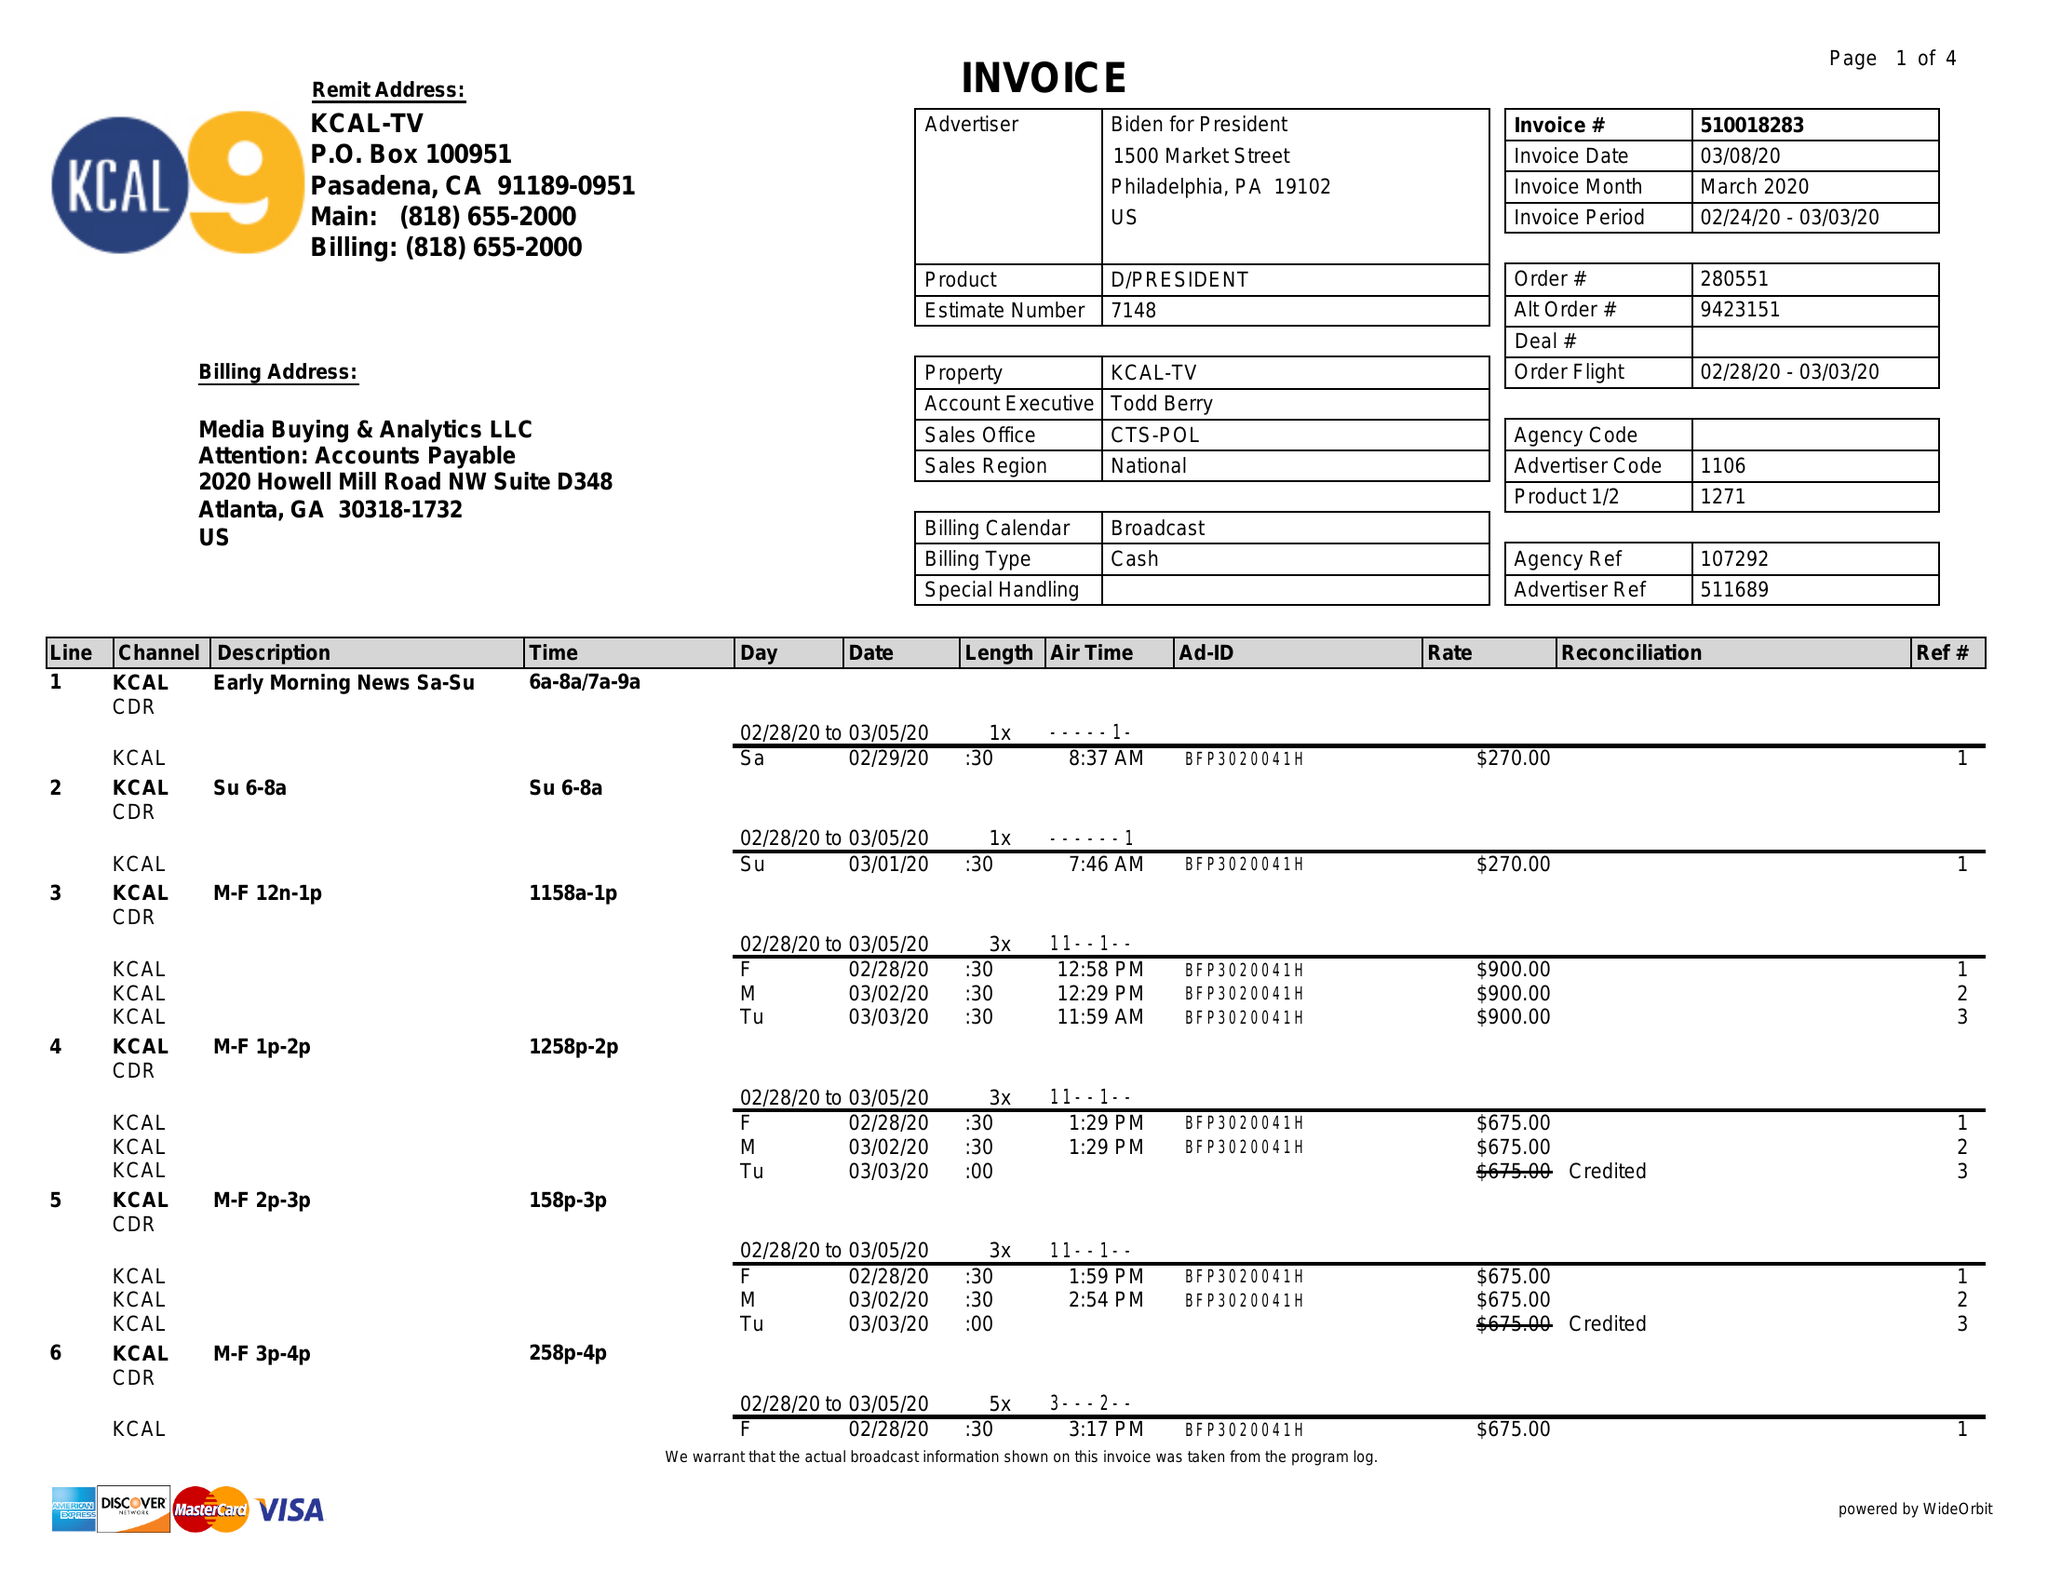What is the value for the advertiser?
Answer the question using a single word or phrase. BIDEN FOR PRESIDENT 